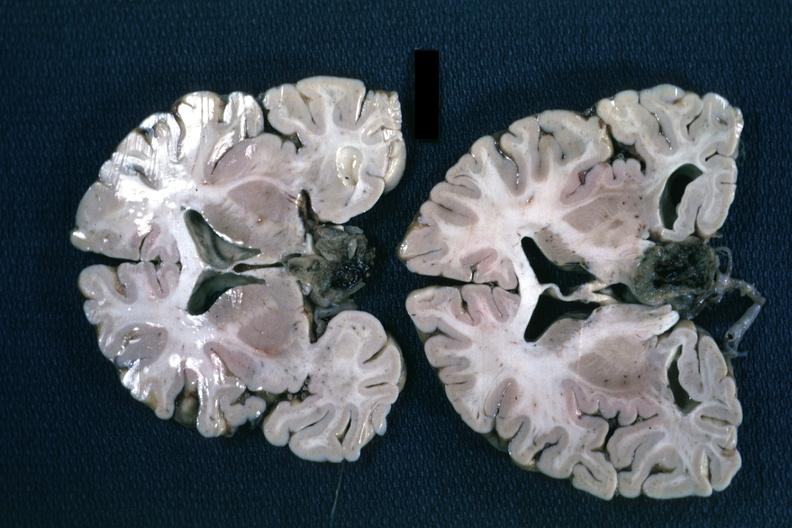s endocrine present?
Answer the question using a single word or phrase. Yes 